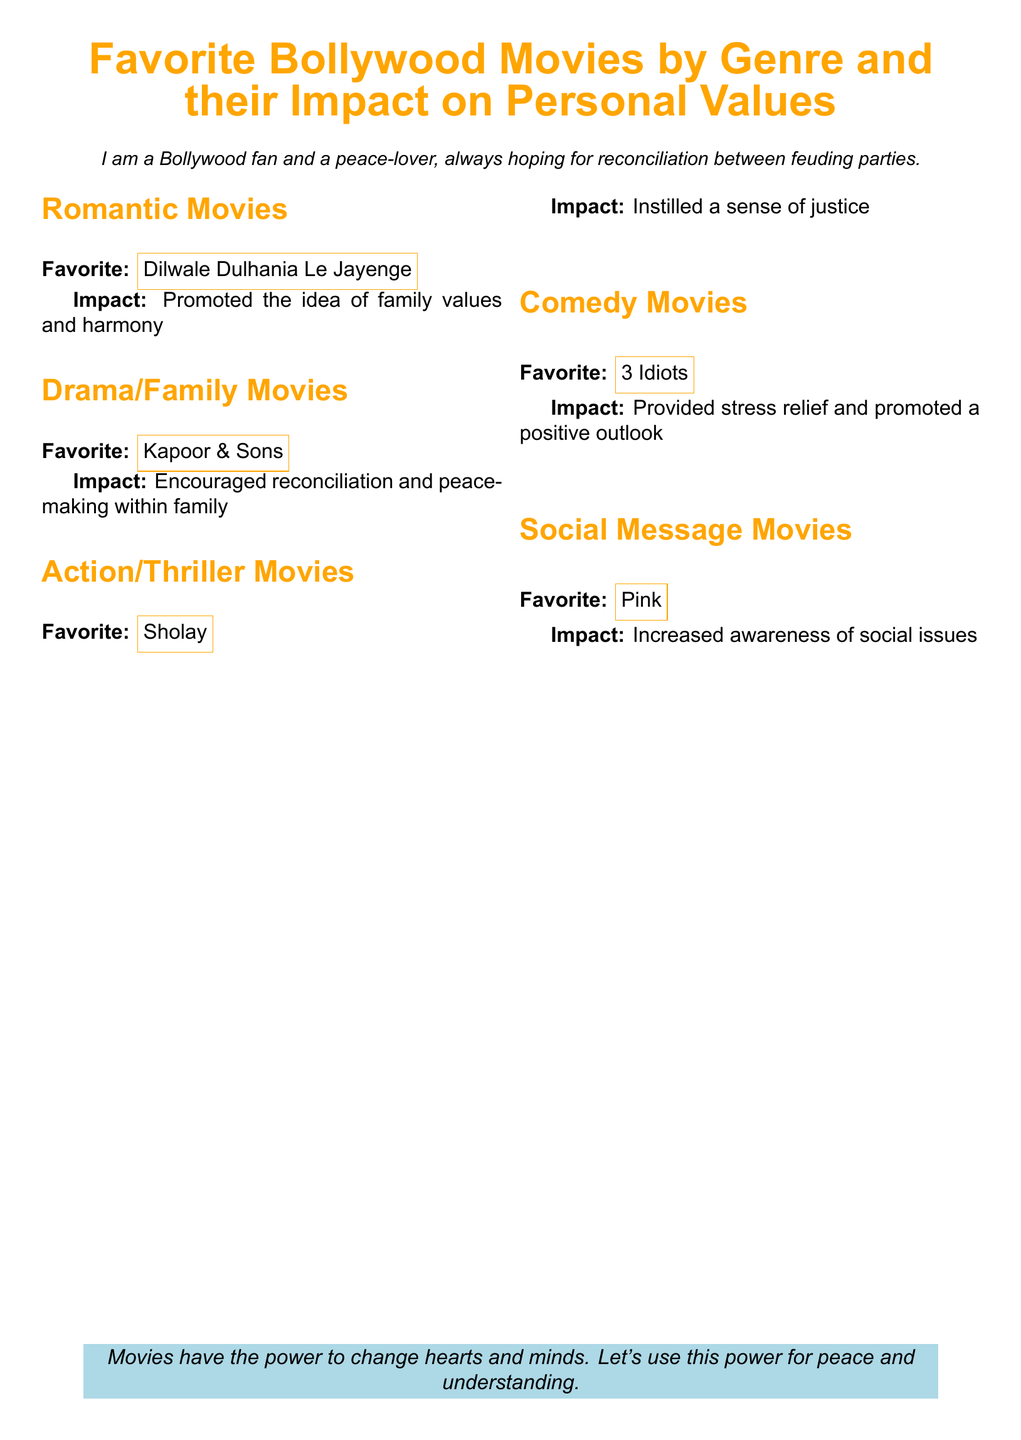What is the favorite romantic movie? The document states the favorite romantic movie under the section 'Romantic Movies'.
Answer: Dilwale Dulhania Le Jayenge What impact does the romantic movie promote? The impact of the romantic movie is listed in the same section, reflecting its themes.
Answer: Family values and harmony Which movie is highlighted in the action/thriller genre? The action/thriller movie is specified in the respective section of the document.
Answer: Sholay What is the personal impact of the comedy movie? The document elaborates on the personal impact of the comedy movie in its section.
Answer: Provided stress relief and promoted a positive outlook What social message movie is mentioned? The document identifies the favorite movie in the social message category.
Answer: Pink What theme is associated with the drama/family movie? The theme for the drama/family movie is found under its section in the document.
Answer: Reconciliation and peace-making within family How many genres of movies are mentioned in total? The total number of genres can be counted from the number of sections in the document.
Answer: Five What overarching message does the document convey about movies? The document concludes with a statement reflecting on the impact of movies.
Answer: Power for peace and understanding 